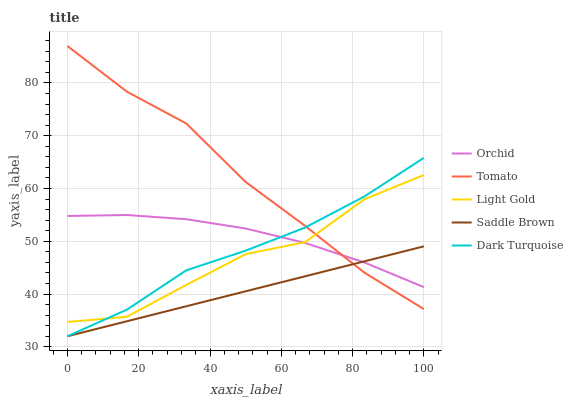Does Saddle Brown have the minimum area under the curve?
Answer yes or no. Yes. Does Tomato have the maximum area under the curve?
Answer yes or no. Yes. Does Dark Turquoise have the minimum area under the curve?
Answer yes or no. No. Does Dark Turquoise have the maximum area under the curve?
Answer yes or no. No. Is Saddle Brown the smoothest?
Answer yes or no. Yes. Is Light Gold the roughest?
Answer yes or no. Yes. Is Dark Turquoise the smoothest?
Answer yes or no. No. Is Dark Turquoise the roughest?
Answer yes or no. No. Does Light Gold have the lowest value?
Answer yes or no. No. Does Tomato have the highest value?
Answer yes or no. Yes. Does Dark Turquoise have the highest value?
Answer yes or no. No. Is Saddle Brown less than Light Gold?
Answer yes or no. Yes. Is Light Gold greater than Saddle Brown?
Answer yes or no. Yes. Does Dark Turquoise intersect Tomato?
Answer yes or no. Yes. Is Dark Turquoise less than Tomato?
Answer yes or no. No. Is Dark Turquoise greater than Tomato?
Answer yes or no. No. Does Saddle Brown intersect Light Gold?
Answer yes or no. No. 